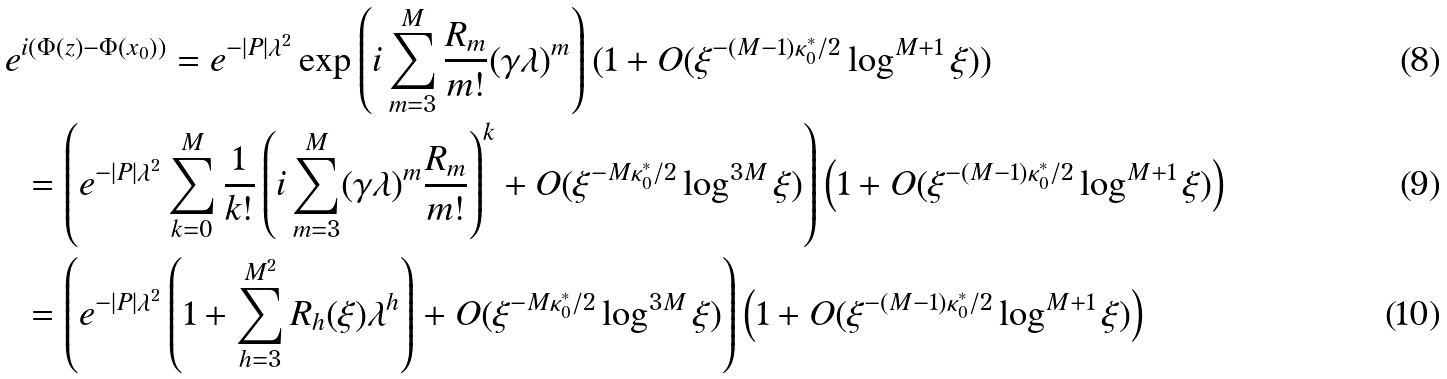<formula> <loc_0><loc_0><loc_500><loc_500>e & ^ { i ( \Phi ( z ) - \Phi ( x _ { 0 } ) ) } = e ^ { - | P | \lambda ^ { 2 } } \exp \left ( i \sum _ { m = 3 } ^ { M } \frac { R _ { m } } { m ! } ( \gamma \lambda ) ^ { m } \right ) ( 1 + O ( \xi ^ { - ( M - 1 ) \kappa _ { 0 } ^ { * } / 2 } \log ^ { M + 1 } \xi ) ) \\ & = \left ( e ^ { - | P | \lambda ^ { 2 } } \sum _ { k = 0 } ^ { M } \frac { 1 } { k ! } \left ( i \sum _ { m = 3 } ^ { M } ( \gamma \lambda ) ^ { m } \frac { R _ { m } } { m ! } \right ) ^ { k } + O ( \xi ^ { - M \kappa _ { 0 } ^ { * } / 2 } \log ^ { 3 M } \xi ) \right ) \left ( 1 + O ( \xi ^ { - ( M - 1 ) \kappa _ { 0 } ^ { * } / 2 } \log ^ { M + 1 } \xi ) \right ) \\ & = \left ( e ^ { - | P | \lambda ^ { 2 } } \left ( 1 + \sum _ { h = 3 } ^ { M ^ { 2 } } R _ { h } ( \xi ) \lambda ^ { h } \right ) + O ( \xi ^ { - M \kappa _ { 0 } ^ { * } / 2 } \log ^ { 3 M } \xi ) \right ) \left ( 1 + O ( \xi ^ { - ( M - 1 ) \kappa _ { 0 } ^ { * } / 2 } \log ^ { M + 1 } \xi ) \right )</formula> 